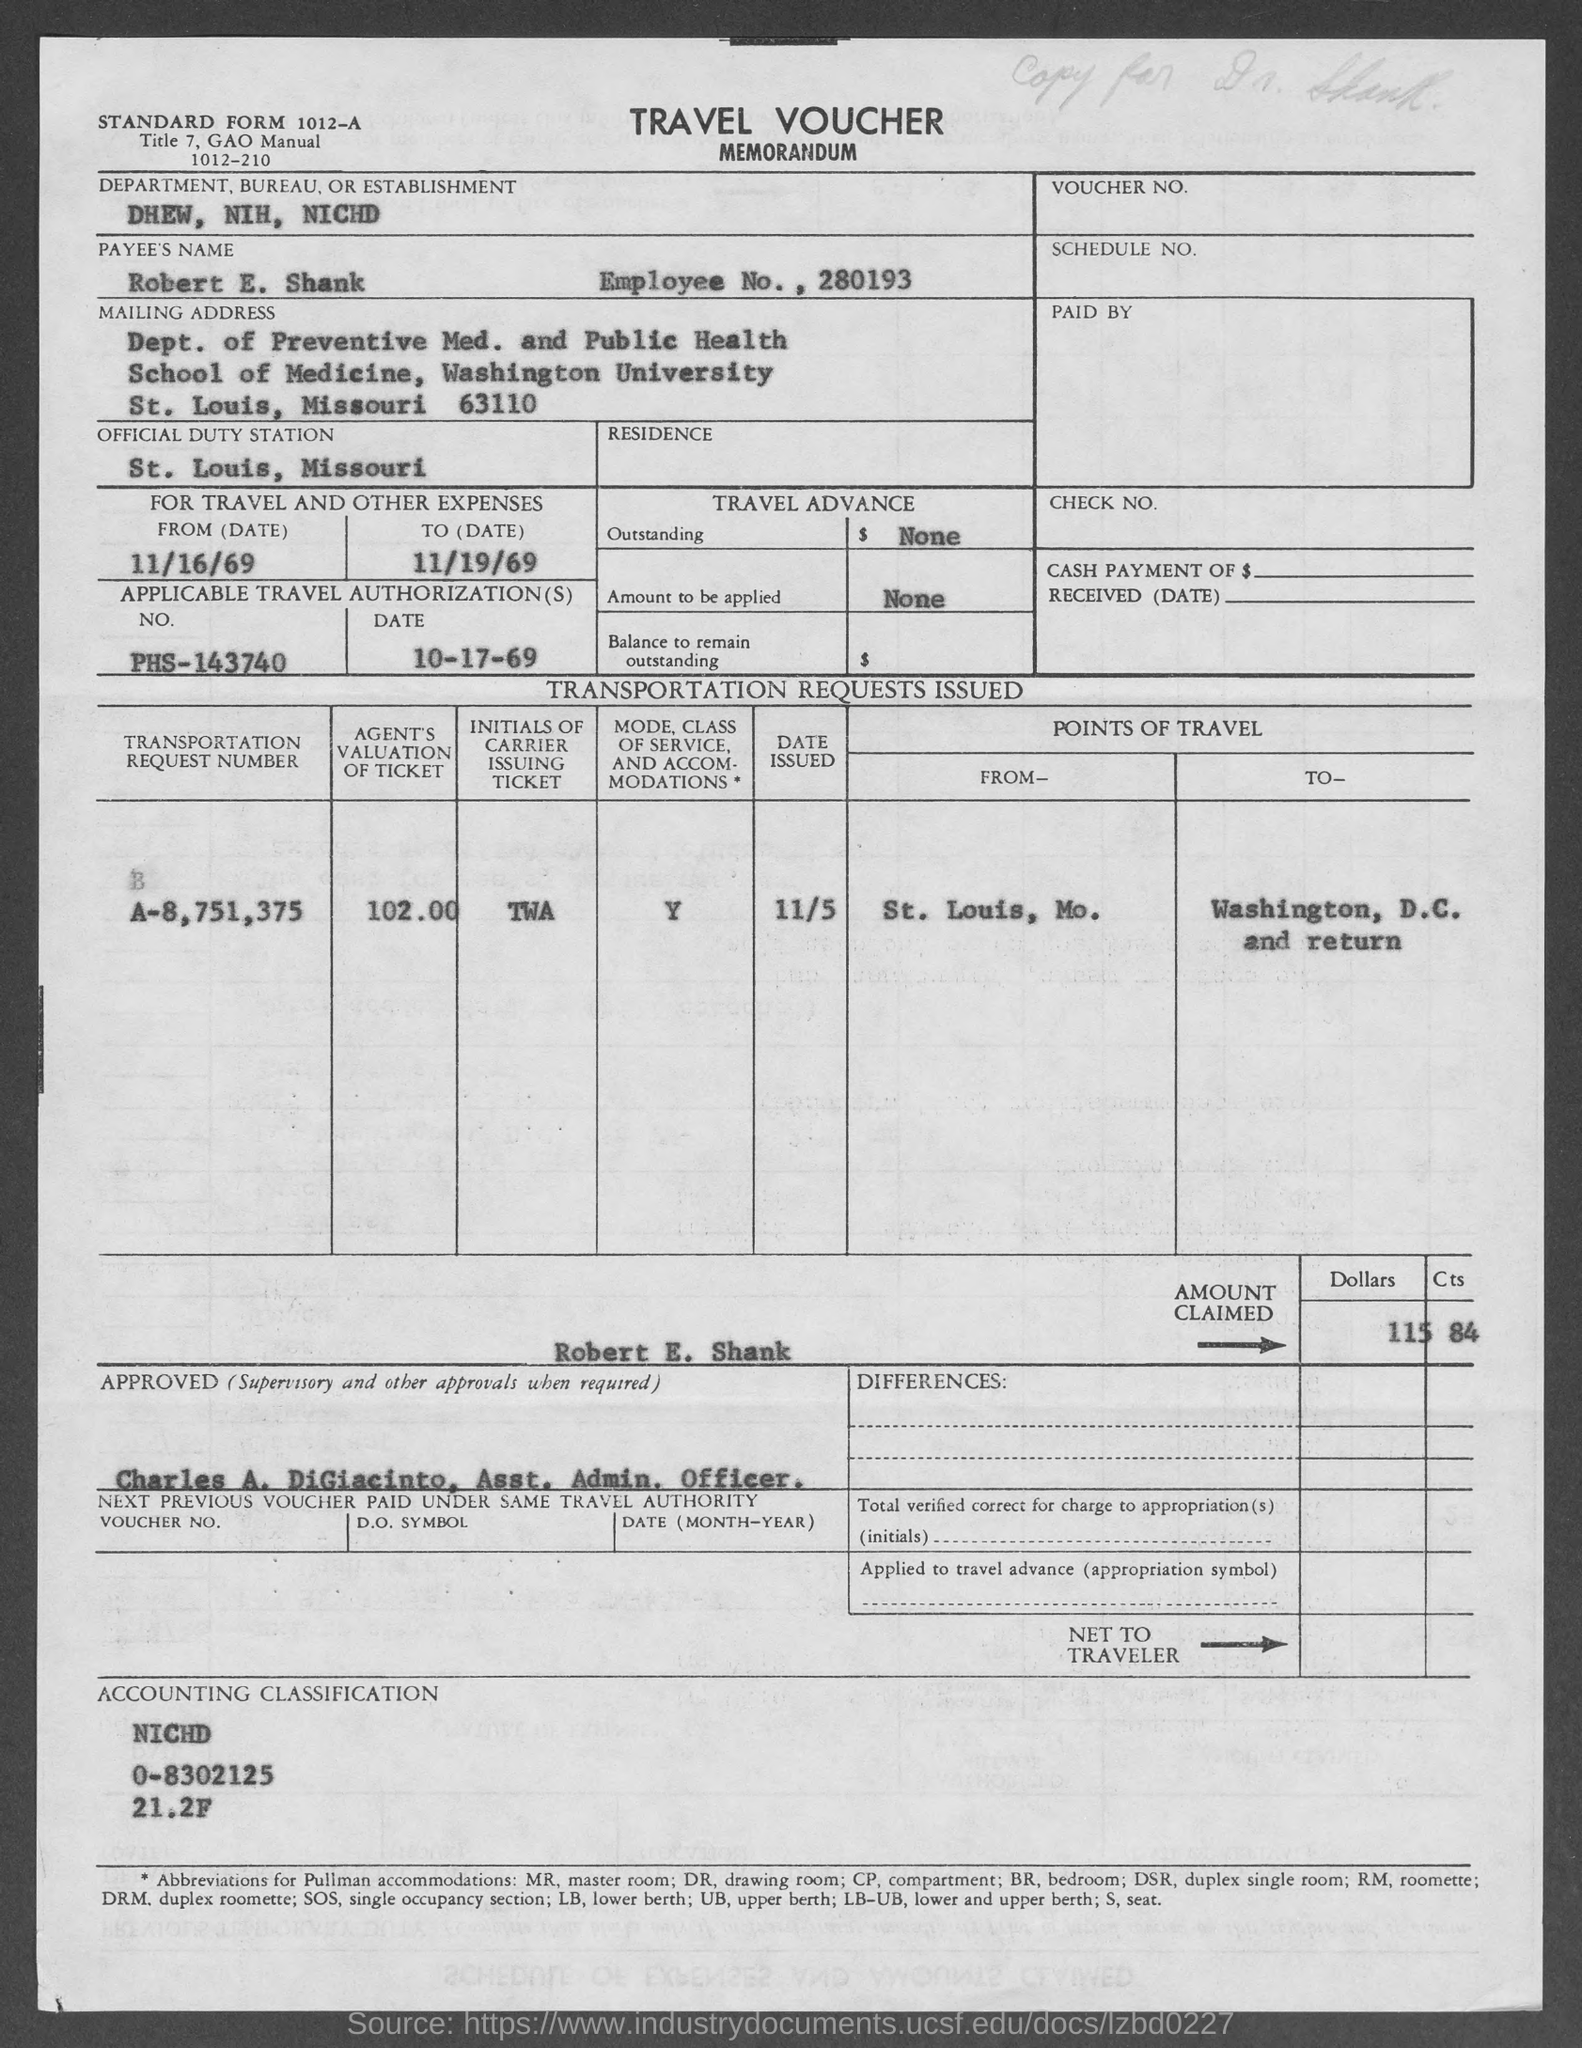What is the Standard Form No. given in the voucher?
Provide a short and direct response. 1012-A. What type of voucher is given here?
Your answer should be very brief. TRAVEL VOUCHER. What is the Department, Bureau, or Establishment mentioned in the voucher?
Your answer should be compact. DHEW, NIH, NICHD. What is the payee's name given in the voucher?
Offer a terse response. Robert E. Shank. What is the Employee No. of Robert E. Shank?
Provide a succinct answer. 280193. Which is the official duty station of Robert E. Shank?
Your answer should be compact. St. Louis, Missouri. What is the applicable travel authorization no. given in the travel voucher?
Ensure brevity in your answer.  PHS-143740. What is the applicable travel authorization date given in the travel voucher?
Offer a very short reply. 10-17-69. What is the transportation request number mentioned in the travel voucher?
Offer a terse response. A-8,751,375. 